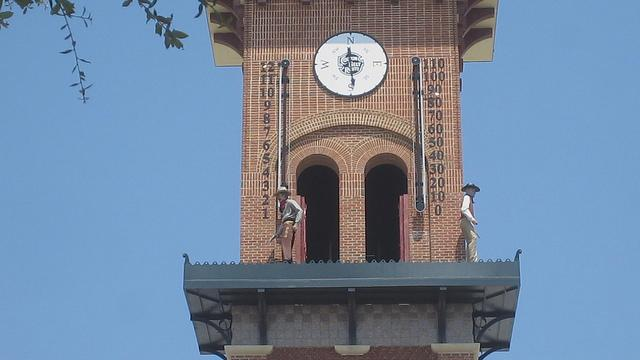What is the device shown in the image? Please explain your reasoning. compass. There is a compass on the side of the tower that shows the directions north, south, east, and west. 